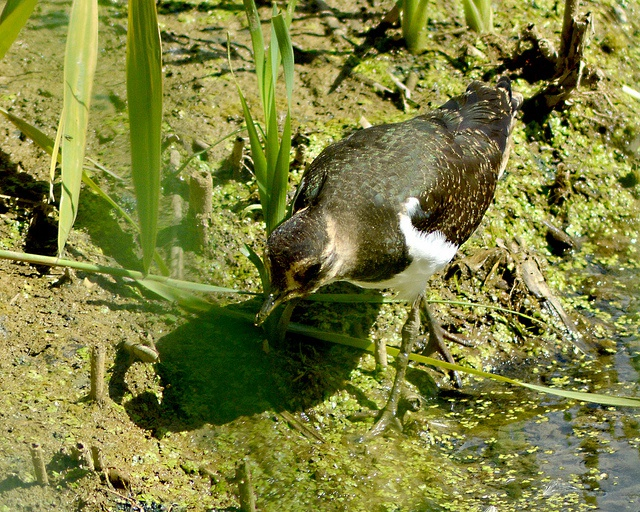Describe the objects in this image and their specific colors. I can see a bird in olive, black, and gray tones in this image. 